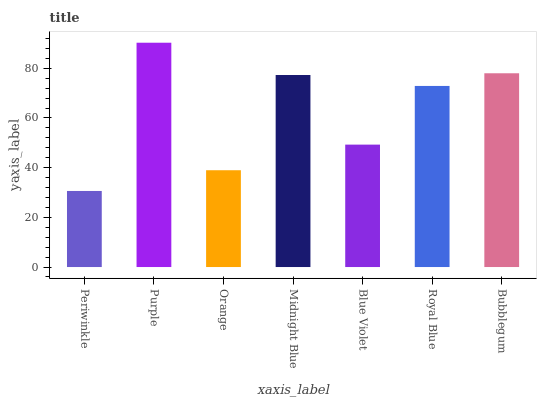Is Periwinkle the minimum?
Answer yes or no. Yes. Is Purple the maximum?
Answer yes or no. Yes. Is Orange the minimum?
Answer yes or no. No. Is Orange the maximum?
Answer yes or no. No. Is Purple greater than Orange?
Answer yes or no. Yes. Is Orange less than Purple?
Answer yes or no. Yes. Is Orange greater than Purple?
Answer yes or no. No. Is Purple less than Orange?
Answer yes or no. No. Is Royal Blue the high median?
Answer yes or no. Yes. Is Royal Blue the low median?
Answer yes or no. Yes. Is Orange the high median?
Answer yes or no. No. Is Orange the low median?
Answer yes or no. No. 